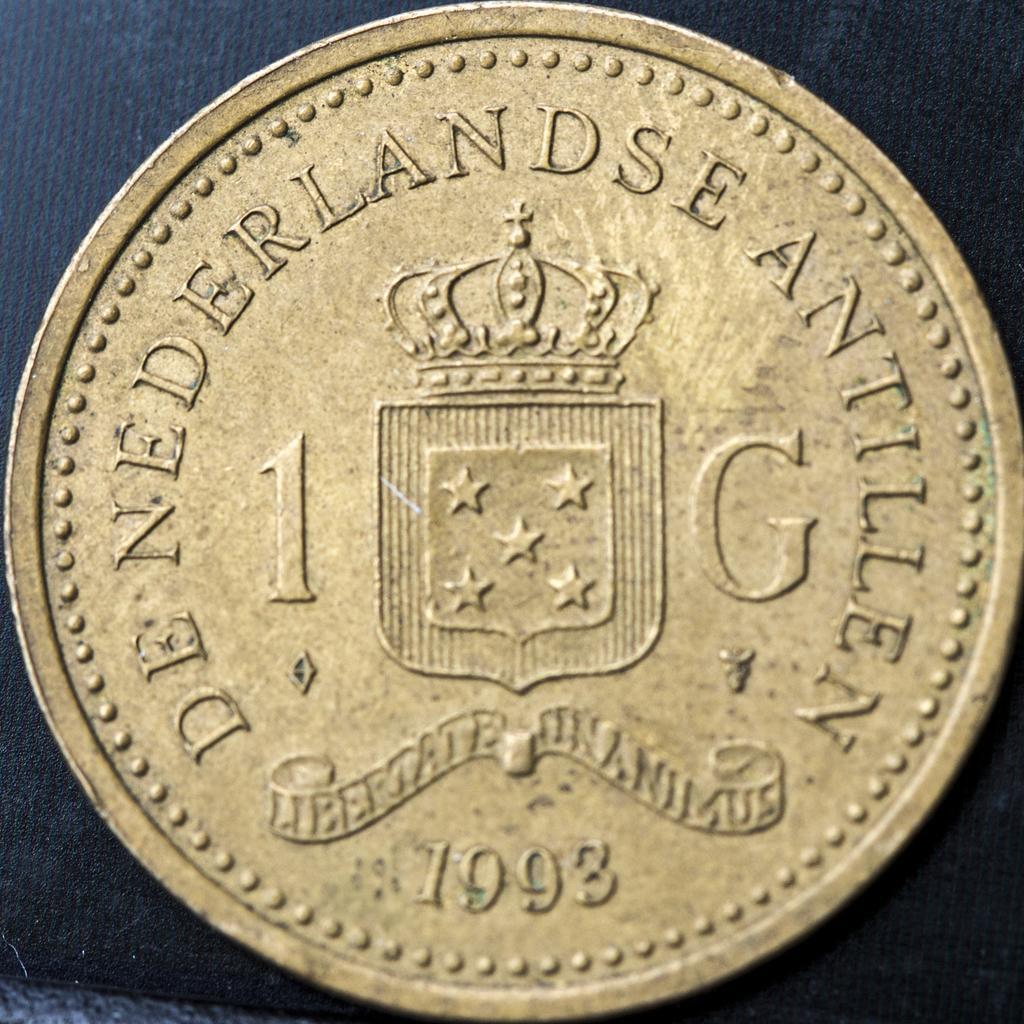<image>
Present a compact description of the photo's key features. A gold colored coin stamped with the date 1993. 